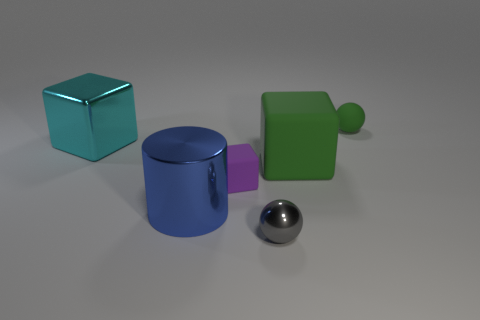Subtract all large blocks. How many blocks are left? 1 Add 2 cyan shiny blocks. How many objects exist? 8 Subtract all balls. How many objects are left? 4 Subtract all blue blocks. Subtract all purple spheres. How many blocks are left? 3 Subtract all large brown metallic objects. Subtract all large blue shiny cylinders. How many objects are left? 5 Add 1 small gray metal balls. How many small gray metal balls are left? 2 Add 1 rubber balls. How many rubber balls exist? 2 Subtract 0 blue blocks. How many objects are left? 6 